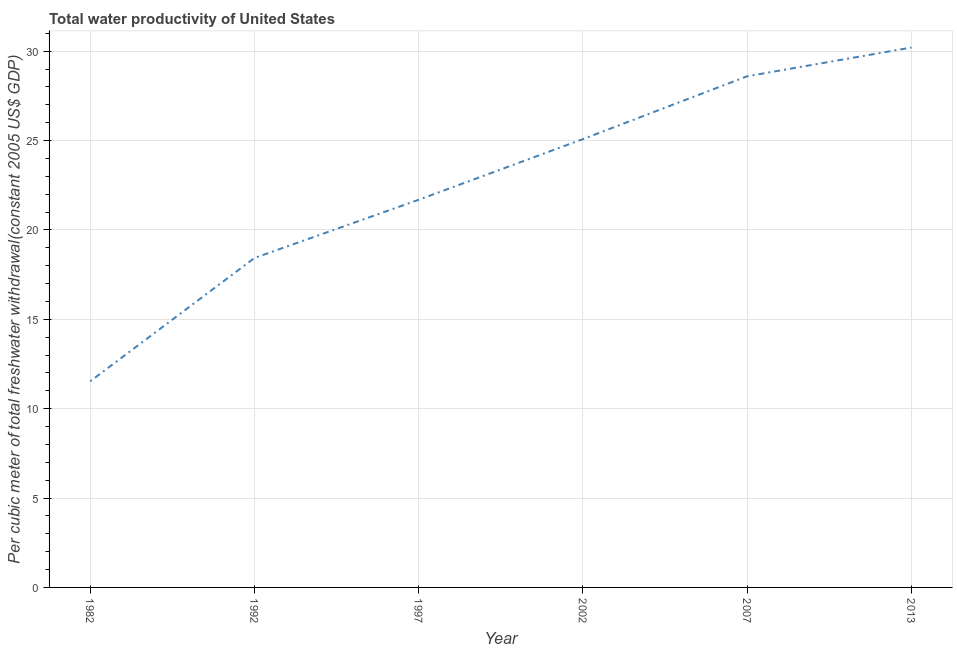What is the total water productivity in 1982?
Your response must be concise. 11.53. Across all years, what is the maximum total water productivity?
Your answer should be very brief. 30.21. Across all years, what is the minimum total water productivity?
Offer a very short reply. 11.53. In which year was the total water productivity minimum?
Your response must be concise. 1982. What is the sum of the total water productivity?
Offer a very short reply. 135.54. What is the difference between the total water productivity in 1992 and 2002?
Your answer should be very brief. -6.65. What is the average total water productivity per year?
Your answer should be very brief. 22.59. What is the median total water productivity?
Provide a short and direct response. 23.39. What is the ratio of the total water productivity in 1992 to that in 2002?
Your answer should be very brief. 0.73. Is the total water productivity in 1997 less than that in 2013?
Offer a very short reply. Yes. Is the difference between the total water productivity in 1992 and 2007 greater than the difference between any two years?
Your response must be concise. No. What is the difference between the highest and the second highest total water productivity?
Give a very brief answer. 1.61. Is the sum of the total water productivity in 1992 and 2007 greater than the maximum total water productivity across all years?
Your answer should be compact. Yes. What is the difference between the highest and the lowest total water productivity?
Your response must be concise. 18.67. How many years are there in the graph?
Give a very brief answer. 6. Are the values on the major ticks of Y-axis written in scientific E-notation?
Ensure brevity in your answer.  No. What is the title of the graph?
Offer a terse response. Total water productivity of United States. What is the label or title of the X-axis?
Offer a very short reply. Year. What is the label or title of the Y-axis?
Offer a very short reply. Per cubic meter of total freshwater withdrawal(constant 2005 US$ GDP). What is the Per cubic meter of total freshwater withdrawal(constant 2005 US$ GDP) in 1982?
Your answer should be compact. 11.53. What is the Per cubic meter of total freshwater withdrawal(constant 2005 US$ GDP) of 1992?
Your answer should be very brief. 18.43. What is the Per cubic meter of total freshwater withdrawal(constant 2005 US$ GDP) in 1997?
Provide a short and direct response. 21.69. What is the Per cubic meter of total freshwater withdrawal(constant 2005 US$ GDP) in 2002?
Offer a very short reply. 25.08. What is the Per cubic meter of total freshwater withdrawal(constant 2005 US$ GDP) of 2007?
Make the answer very short. 28.6. What is the Per cubic meter of total freshwater withdrawal(constant 2005 US$ GDP) of 2013?
Your answer should be compact. 30.21. What is the difference between the Per cubic meter of total freshwater withdrawal(constant 2005 US$ GDP) in 1982 and 1992?
Offer a terse response. -6.9. What is the difference between the Per cubic meter of total freshwater withdrawal(constant 2005 US$ GDP) in 1982 and 1997?
Your response must be concise. -10.16. What is the difference between the Per cubic meter of total freshwater withdrawal(constant 2005 US$ GDP) in 1982 and 2002?
Give a very brief answer. -13.55. What is the difference between the Per cubic meter of total freshwater withdrawal(constant 2005 US$ GDP) in 1982 and 2007?
Offer a very short reply. -17.07. What is the difference between the Per cubic meter of total freshwater withdrawal(constant 2005 US$ GDP) in 1982 and 2013?
Offer a very short reply. -18.67. What is the difference between the Per cubic meter of total freshwater withdrawal(constant 2005 US$ GDP) in 1992 and 1997?
Your response must be concise. -3.26. What is the difference between the Per cubic meter of total freshwater withdrawal(constant 2005 US$ GDP) in 1992 and 2002?
Give a very brief answer. -6.65. What is the difference between the Per cubic meter of total freshwater withdrawal(constant 2005 US$ GDP) in 1992 and 2007?
Make the answer very short. -10.17. What is the difference between the Per cubic meter of total freshwater withdrawal(constant 2005 US$ GDP) in 1992 and 2013?
Offer a very short reply. -11.78. What is the difference between the Per cubic meter of total freshwater withdrawal(constant 2005 US$ GDP) in 1997 and 2002?
Ensure brevity in your answer.  -3.39. What is the difference between the Per cubic meter of total freshwater withdrawal(constant 2005 US$ GDP) in 1997 and 2007?
Provide a succinct answer. -6.91. What is the difference between the Per cubic meter of total freshwater withdrawal(constant 2005 US$ GDP) in 1997 and 2013?
Your response must be concise. -8.52. What is the difference between the Per cubic meter of total freshwater withdrawal(constant 2005 US$ GDP) in 2002 and 2007?
Provide a short and direct response. -3.52. What is the difference between the Per cubic meter of total freshwater withdrawal(constant 2005 US$ GDP) in 2002 and 2013?
Provide a succinct answer. -5.12. What is the difference between the Per cubic meter of total freshwater withdrawal(constant 2005 US$ GDP) in 2007 and 2013?
Your answer should be very brief. -1.61. What is the ratio of the Per cubic meter of total freshwater withdrawal(constant 2005 US$ GDP) in 1982 to that in 1992?
Keep it short and to the point. 0.63. What is the ratio of the Per cubic meter of total freshwater withdrawal(constant 2005 US$ GDP) in 1982 to that in 1997?
Your response must be concise. 0.53. What is the ratio of the Per cubic meter of total freshwater withdrawal(constant 2005 US$ GDP) in 1982 to that in 2002?
Offer a terse response. 0.46. What is the ratio of the Per cubic meter of total freshwater withdrawal(constant 2005 US$ GDP) in 1982 to that in 2007?
Give a very brief answer. 0.4. What is the ratio of the Per cubic meter of total freshwater withdrawal(constant 2005 US$ GDP) in 1982 to that in 2013?
Provide a short and direct response. 0.38. What is the ratio of the Per cubic meter of total freshwater withdrawal(constant 2005 US$ GDP) in 1992 to that in 1997?
Your response must be concise. 0.85. What is the ratio of the Per cubic meter of total freshwater withdrawal(constant 2005 US$ GDP) in 1992 to that in 2002?
Offer a terse response. 0.73. What is the ratio of the Per cubic meter of total freshwater withdrawal(constant 2005 US$ GDP) in 1992 to that in 2007?
Provide a succinct answer. 0.64. What is the ratio of the Per cubic meter of total freshwater withdrawal(constant 2005 US$ GDP) in 1992 to that in 2013?
Offer a terse response. 0.61. What is the ratio of the Per cubic meter of total freshwater withdrawal(constant 2005 US$ GDP) in 1997 to that in 2002?
Offer a terse response. 0.86. What is the ratio of the Per cubic meter of total freshwater withdrawal(constant 2005 US$ GDP) in 1997 to that in 2007?
Ensure brevity in your answer.  0.76. What is the ratio of the Per cubic meter of total freshwater withdrawal(constant 2005 US$ GDP) in 1997 to that in 2013?
Make the answer very short. 0.72. What is the ratio of the Per cubic meter of total freshwater withdrawal(constant 2005 US$ GDP) in 2002 to that in 2007?
Provide a short and direct response. 0.88. What is the ratio of the Per cubic meter of total freshwater withdrawal(constant 2005 US$ GDP) in 2002 to that in 2013?
Offer a terse response. 0.83. What is the ratio of the Per cubic meter of total freshwater withdrawal(constant 2005 US$ GDP) in 2007 to that in 2013?
Provide a short and direct response. 0.95. 